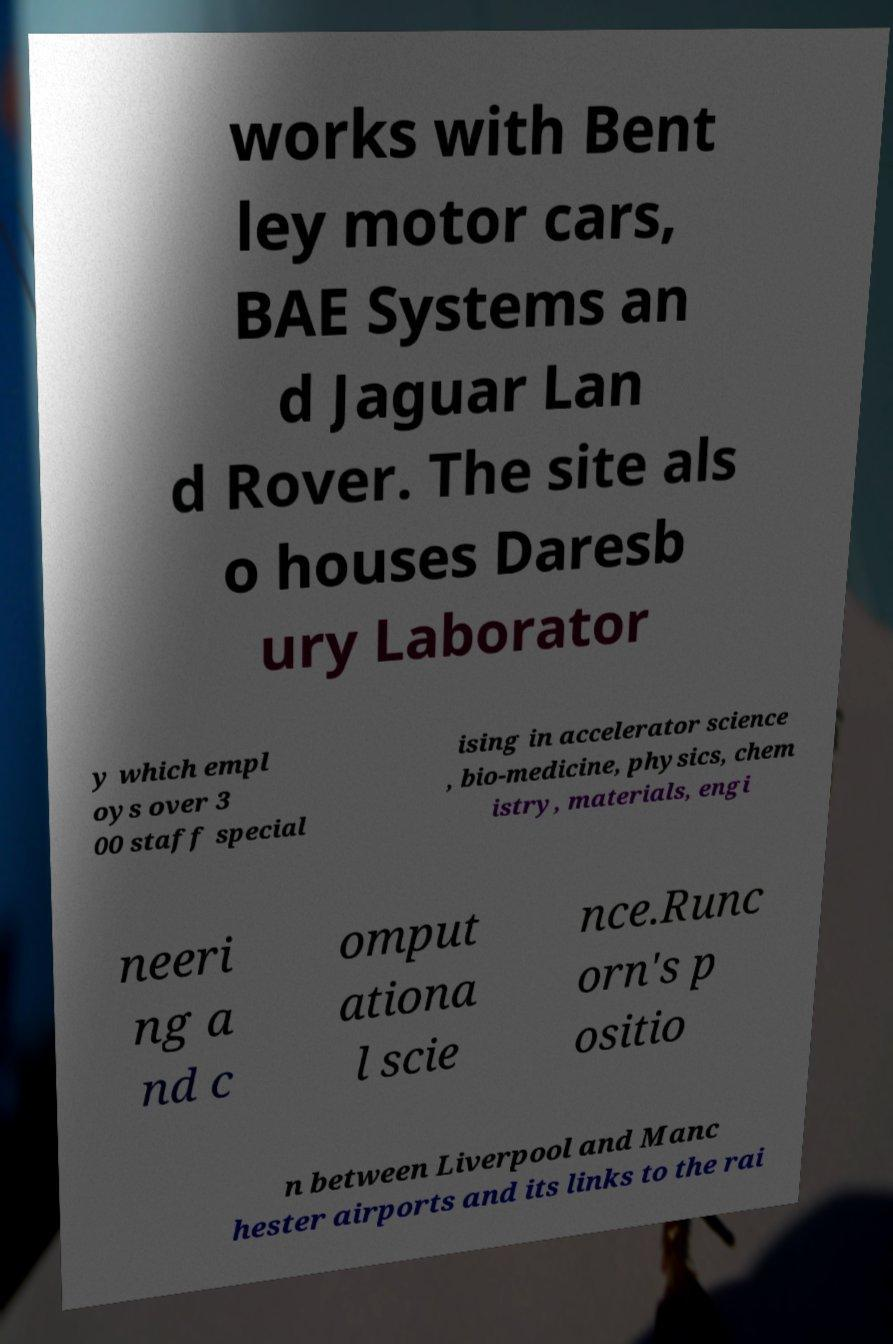I need the written content from this picture converted into text. Can you do that? works with Bent ley motor cars, BAE Systems an d Jaguar Lan d Rover. The site als o houses Daresb ury Laborator y which empl oys over 3 00 staff special ising in accelerator science , bio-medicine, physics, chem istry, materials, engi neeri ng a nd c omput ationa l scie nce.Runc orn's p ositio n between Liverpool and Manc hester airports and its links to the rai 